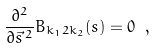<formula> <loc_0><loc_0><loc_500><loc_500>\frac { \partial ^ { 2 } } { \partial \vec { s } ^ { \, 2 } } B _ { k _ { 1 } 2 k _ { 2 } } ( s ) = 0 \ ,</formula> 